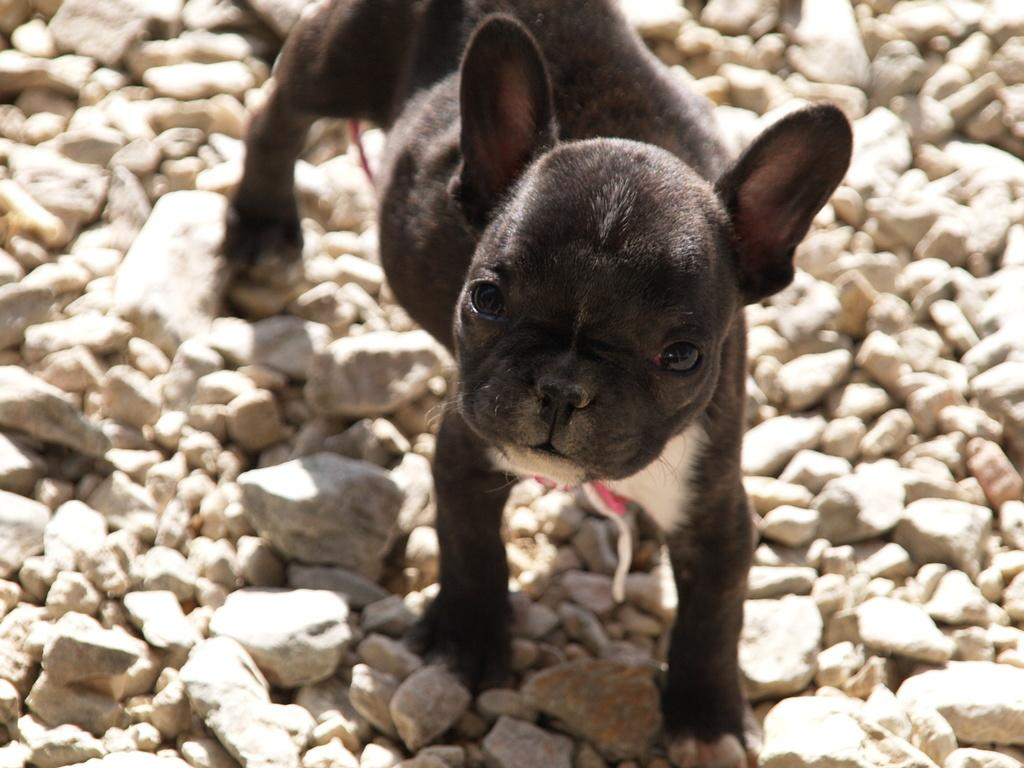What type of animal is in the image? There is a black color dog in the image. What is the dog standing on? The dog is on stones. What type of drug is the dog injecting with a needle in the image? There is no drug or needle present in the image; it only features a black color dog standing on stones. 